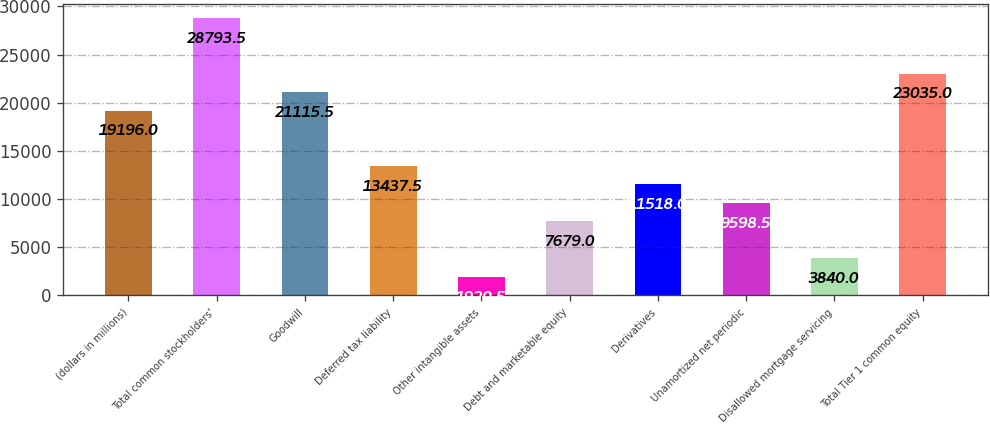Convert chart to OTSL. <chart><loc_0><loc_0><loc_500><loc_500><bar_chart><fcel>(dollars in millions)<fcel>Total common stockholders'<fcel>Goodwill<fcel>Deferred tax liability<fcel>Other intangible assets<fcel>Debt and marketable equity<fcel>Derivatives<fcel>Unamortized net periodic<fcel>Disallowed mortgage servicing<fcel>Total Tier 1 common equity<nl><fcel>19196<fcel>28793.5<fcel>21115.5<fcel>13437.5<fcel>1920.5<fcel>7679<fcel>11518<fcel>9598.5<fcel>3840<fcel>23035<nl></chart> 